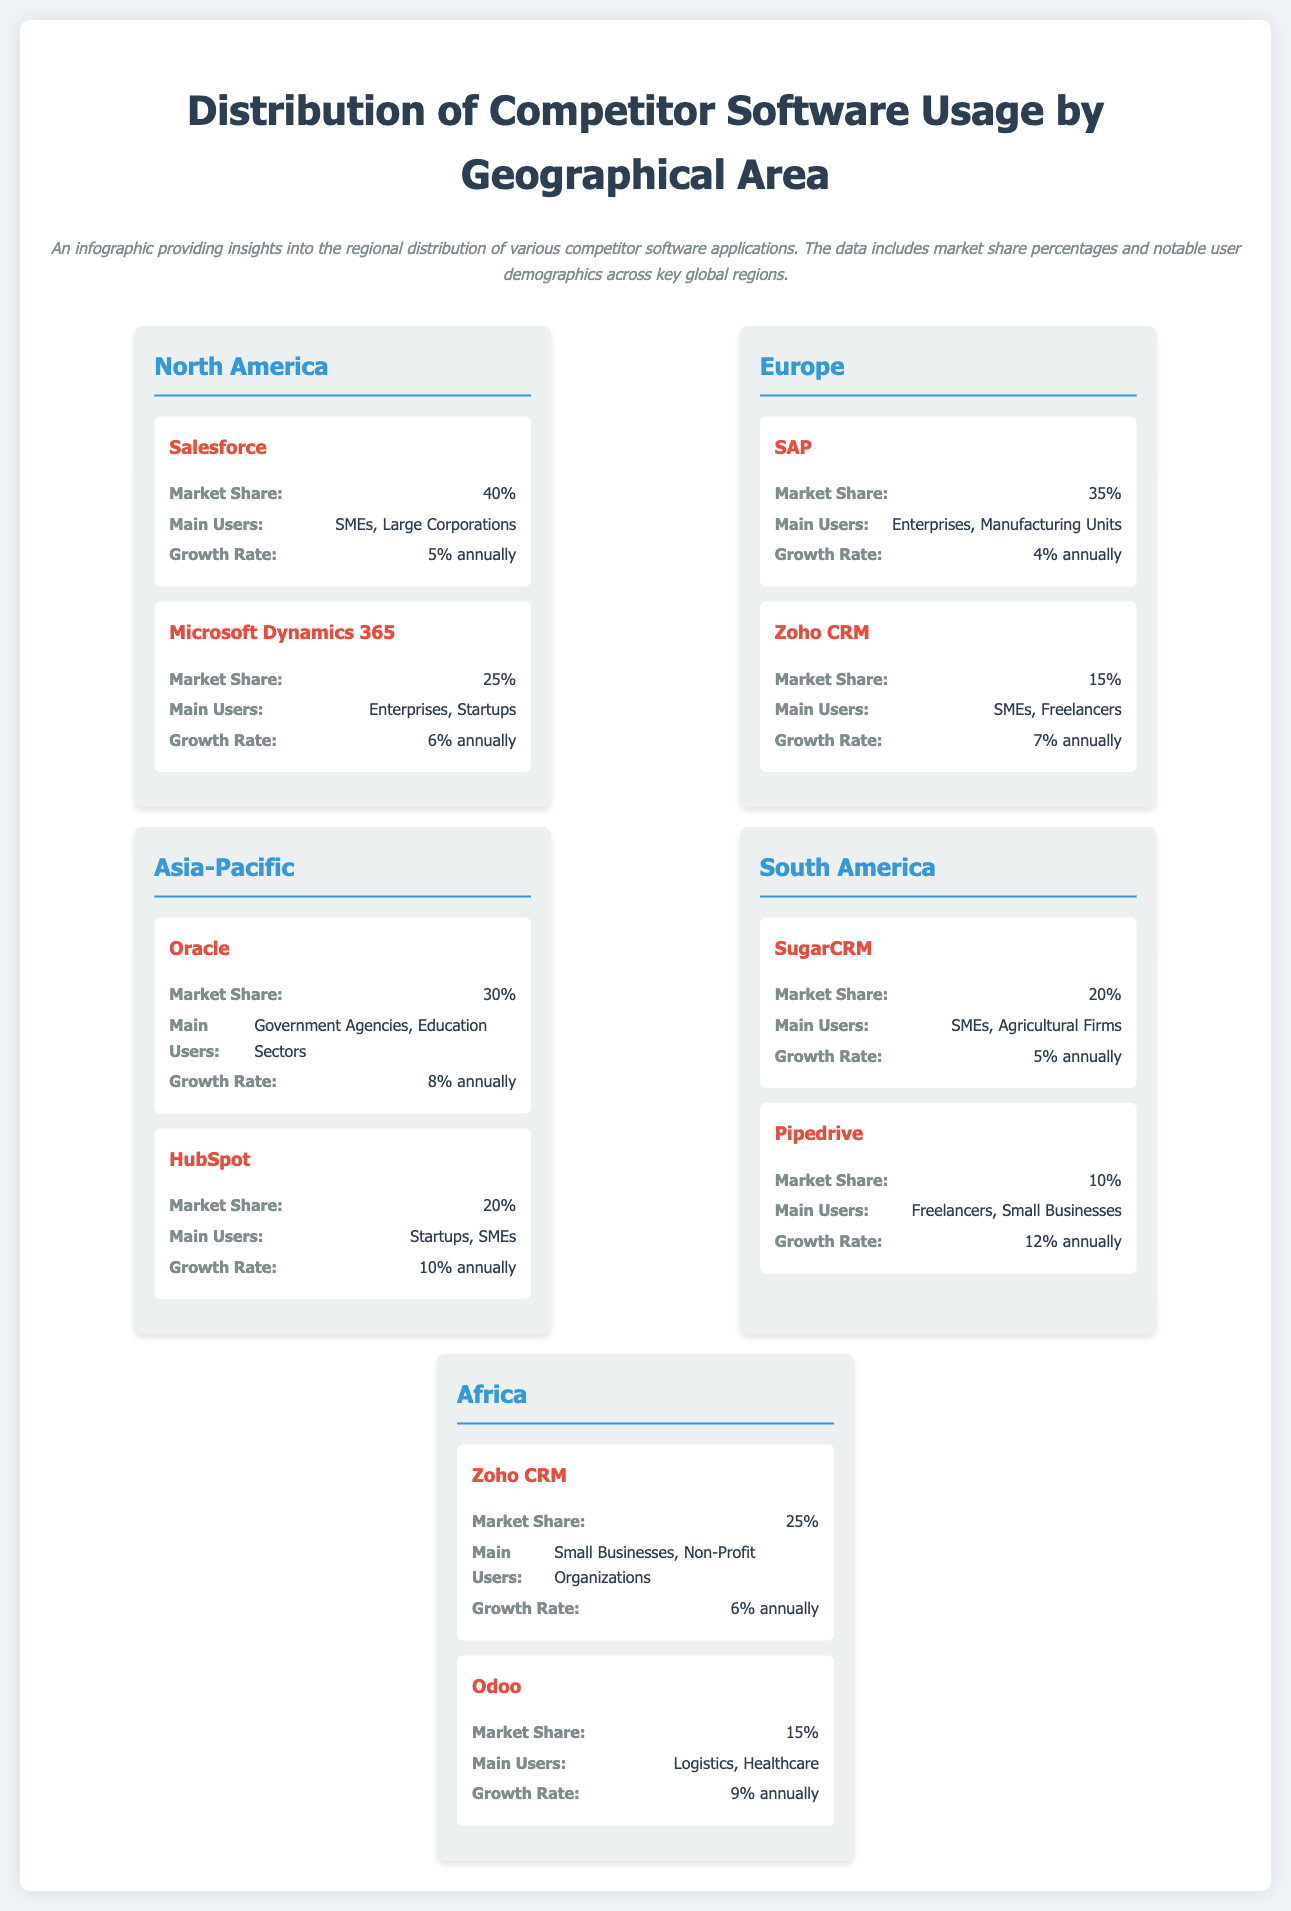What is the market share of Salesforce in North America? The document states that Salesforce has a market share of 40% in North America.
Answer: 40% Which competitor has the highest market share in Europe? According to the document, SAP has the highest market share in Europe at 35%.
Answer: SAP What is the main user demographic for HubSpot in the Asia-Pacific region? The document indicates that HubSpot's main users are Startups and SMEs in the Asia-Pacific region.
Answer: Startups, SMEs What is the annual growth rate of Pipedrive in South America? The growth rate for Pipedrive in South America is mentioned as 12% annually.
Answer: 12% annually In which continent is Oracle primarily used by Government Agencies? The document specifies that Oracle is primarily used by Government Agencies in the Asia-Pacific region.
Answer: Asia-Pacific Which competitor maintains a 25% market share in Africa? The document states that Zoho CRM maintains a 25% market share in Africa.
Answer: Zoho CRM What is the combined market share of the two mentioned competitors in South America? The market shares of SugarCRM (20%) and Pipedrive (10%) total up to a combined market share of 30% in South America.
Answer: 30% Which competitor shows the highest growth rate among those listed? The highest growth rate is indicated as HubSpot with 10% annually.
Answer: HubSpot What type of organizations primarily use Odoo in Africa? The document reveals that Odoo is primarily used by Logistics and Healthcare sectors in Africa.
Answer: Logistics, Healthcare 